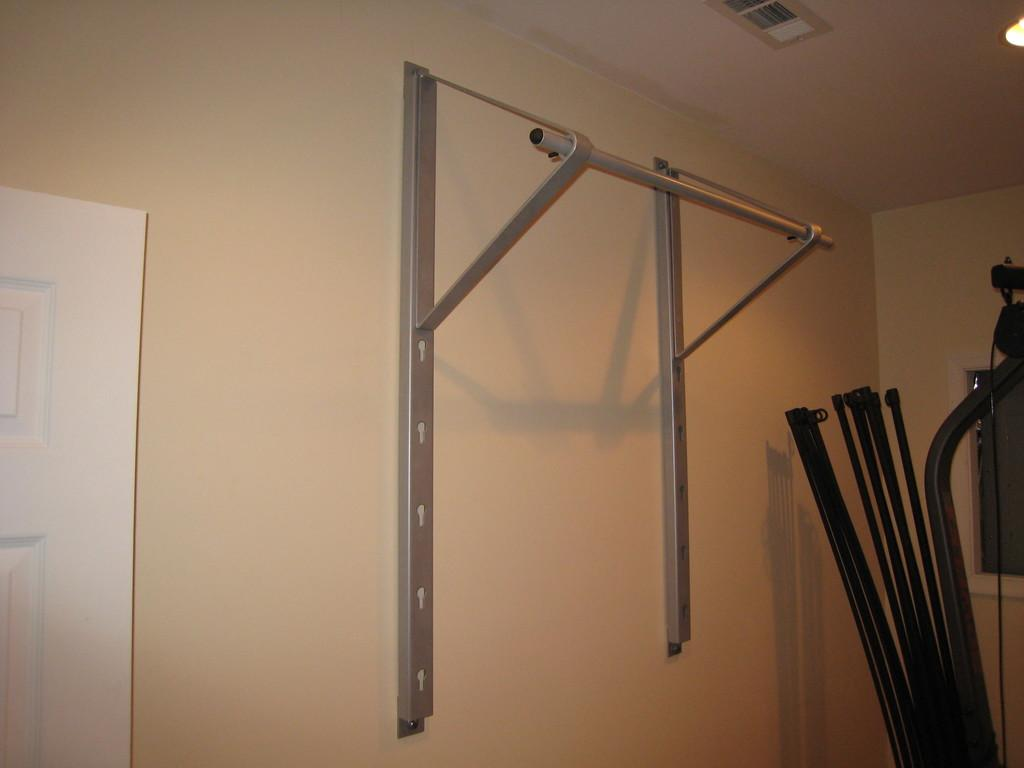What type of location is depicted in the image? The image is an inside view of a room. What can be seen attached to the wall in the middle of the image? There are metal stands attached to the wall in the middle of the image. What objects are on the right side of the image? There are rods on the right side of the image. Where is the door located in the image? There is a door on the left side of the image. What type of lettuce is being served on the plate in the image? There is no plate or lettuce present in the image. Can you see a boat in the image? No, there is no boat visible in the image. 